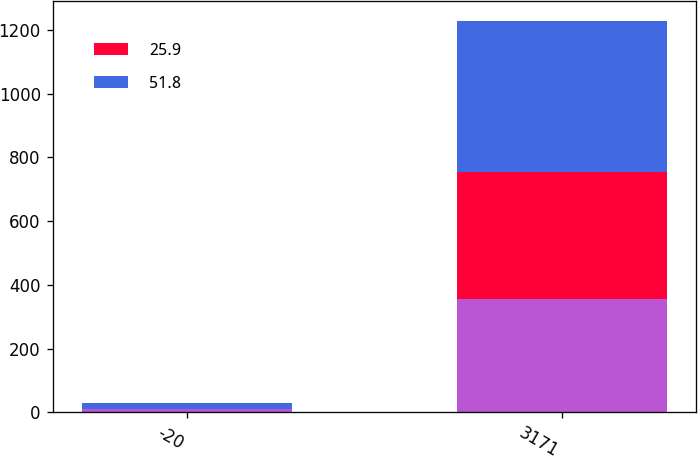Convert chart to OTSL. <chart><loc_0><loc_0><loc_500><loc_500><stacked_bar_chart><ecel><fcel>-20<fcel>3171<nl><fcel>nan<fcel>10<fcel>356.7<nl><fcel>25.9<fcel>0<fcel>396.3<nl><fcel>51.8<fcel>20<fcel>475.6<nl></chart> 